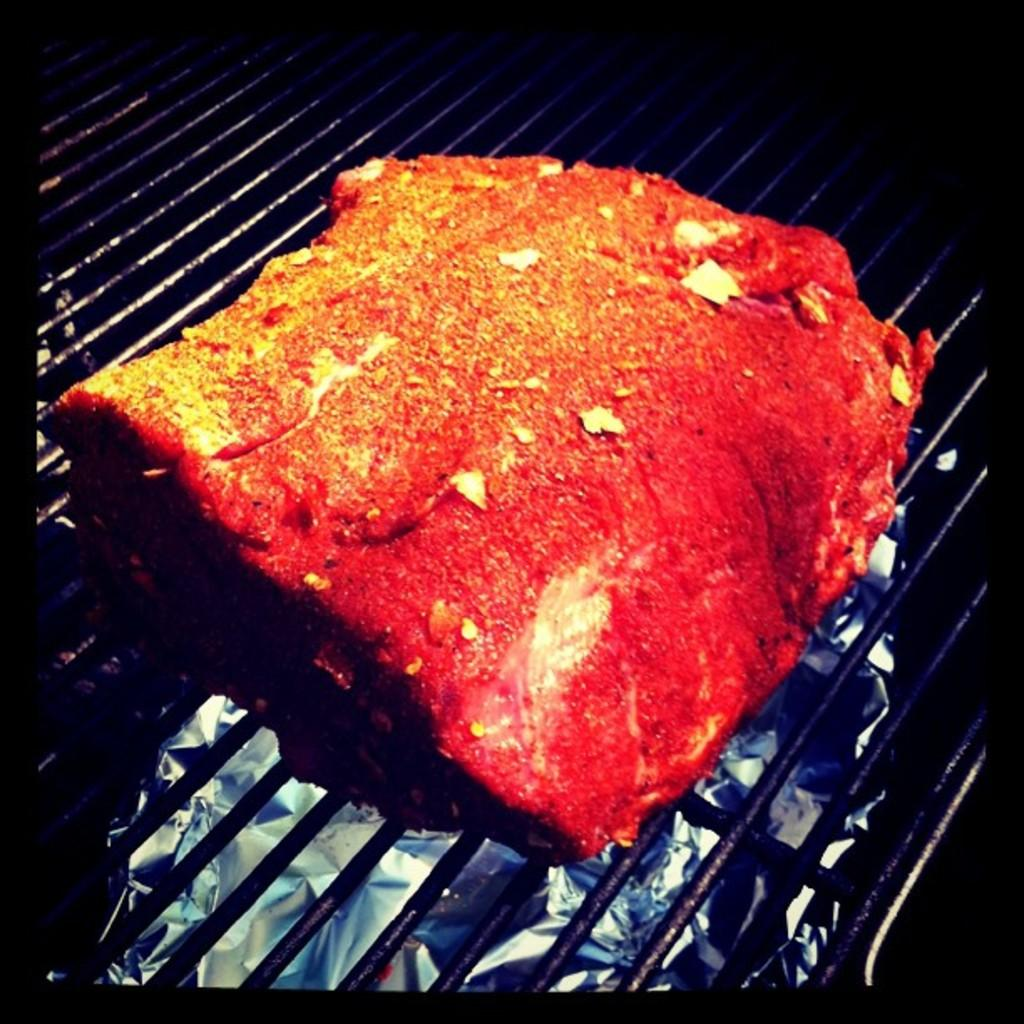What is being cooked in the image? There is food on a grill in the image. Where is the grill located in the image? The grill is in the center of the image. What type of humor can be seen in the image? There is no humor present in the image; it features food on a grill. Is there any poison visible in the image? There is no poison present in the image; it features food on a grill. 